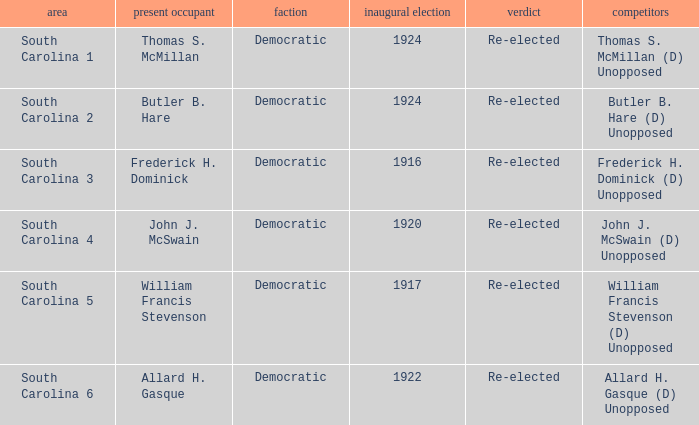Who is the candidate in district south carolina 2? Butler B. Hare (D) Unopposed. 